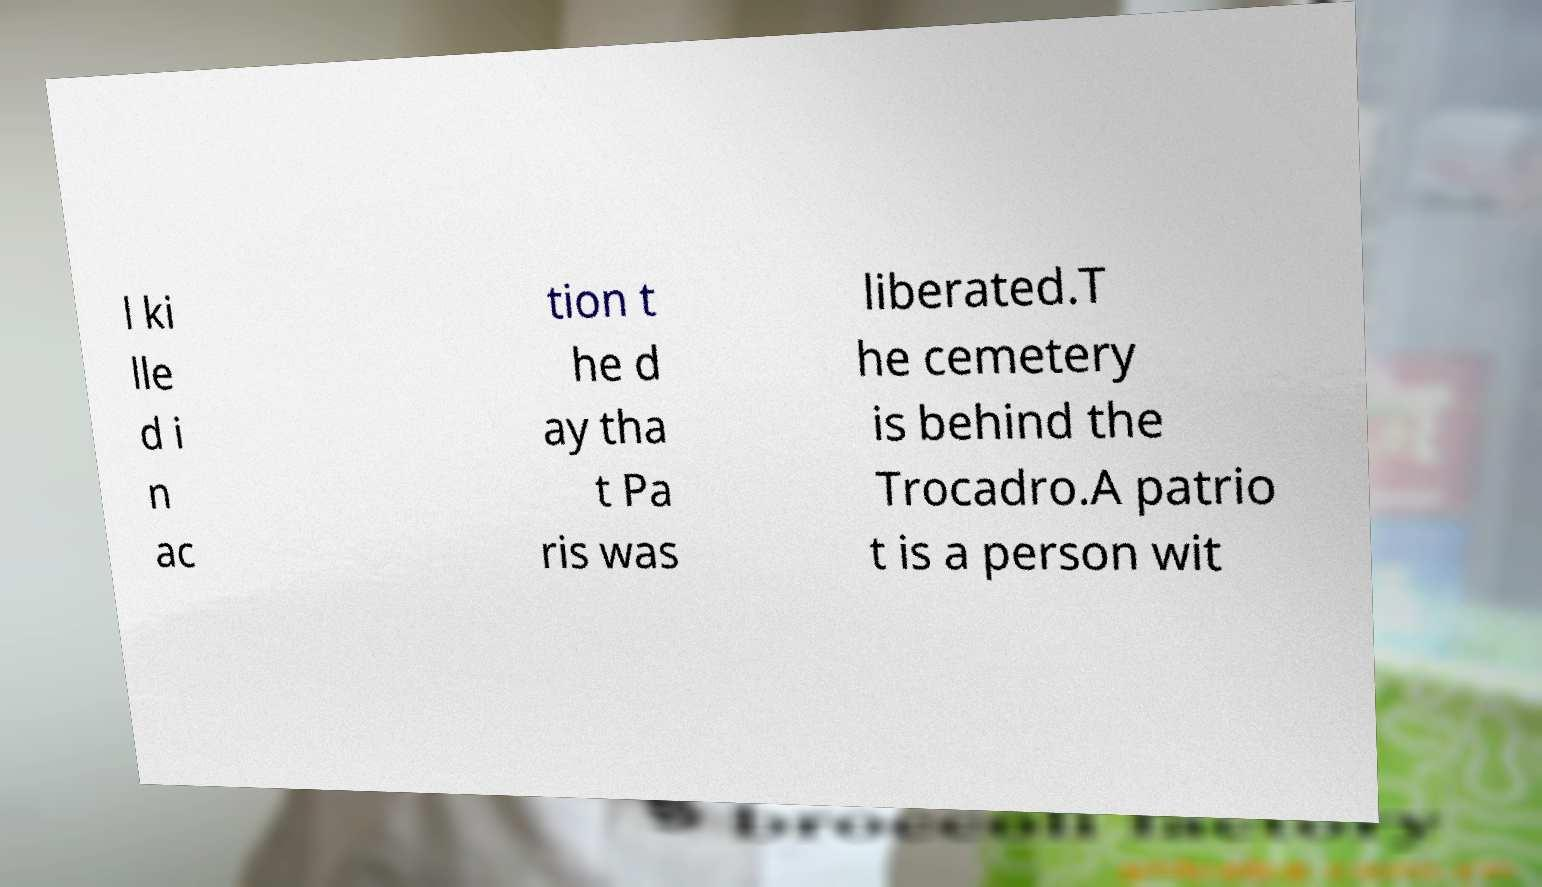Can you read and provide the text displayed in the image?This photo seems to have some interesting text. Can you extract and type it out for me? l ki lle d i n ac tion t he d ay tha t Pa ris was liberated.T he cemetery is behind the Trocadro.A patrio t is a person wit 